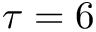<formula> <loc_0><loc_0><loc_500><loc_500>\tau = 6</formula> 